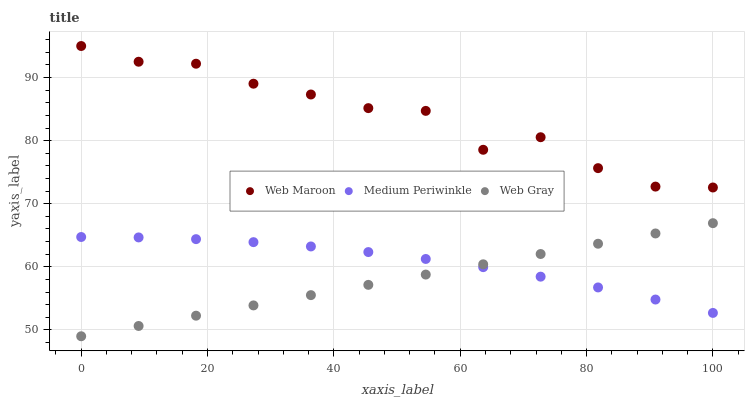Does Web Gray have the minimum area under the curve?
Answer yes or no. Yes. Does Web Maroon have the maximum area under the curve?
Answer yes or no. Yes. Does Web Maroon have the minimum area under the curve?
Answer yes or no. No. Does Web Gray have the maximum area under the curve?
Answer yes or no. No. Is Web Gray the smoothest?
Answer yes or no. Yes. Is Web Maroon the roughest?
Answer yes or no. Yes. Is Web Maroon the smoothest?
Answer yes or no. No. Is Web Gray the roughest?
Answer yes or no. No. Does Web Gray have the lowest value?
Answer yes or no. Yes. Does Web Maroon have the lowest value?
Answer yes or no. No. Does Web Maroon have the highest value?
Answer yes or no. Yes. Does Web Gray have the highest value?
Answer yes or no. No. Is Web Gray less than Web Maroon?
Answer yes or no. Yes. Is Web Maroon greater than Web Gray?
Answer yes or no. Yes. Does Medium Periwinkle intersect Web Gray?
Answer yes or no. Yes. Is Medium Periwinkle less than Web Gray?
Answer yes or no. No. Is Medium Periwinkle greater than Web Gray?
Answer yes or no. No. Does Web Gray intersect Web Maroon?
Answer yes or no. No. 